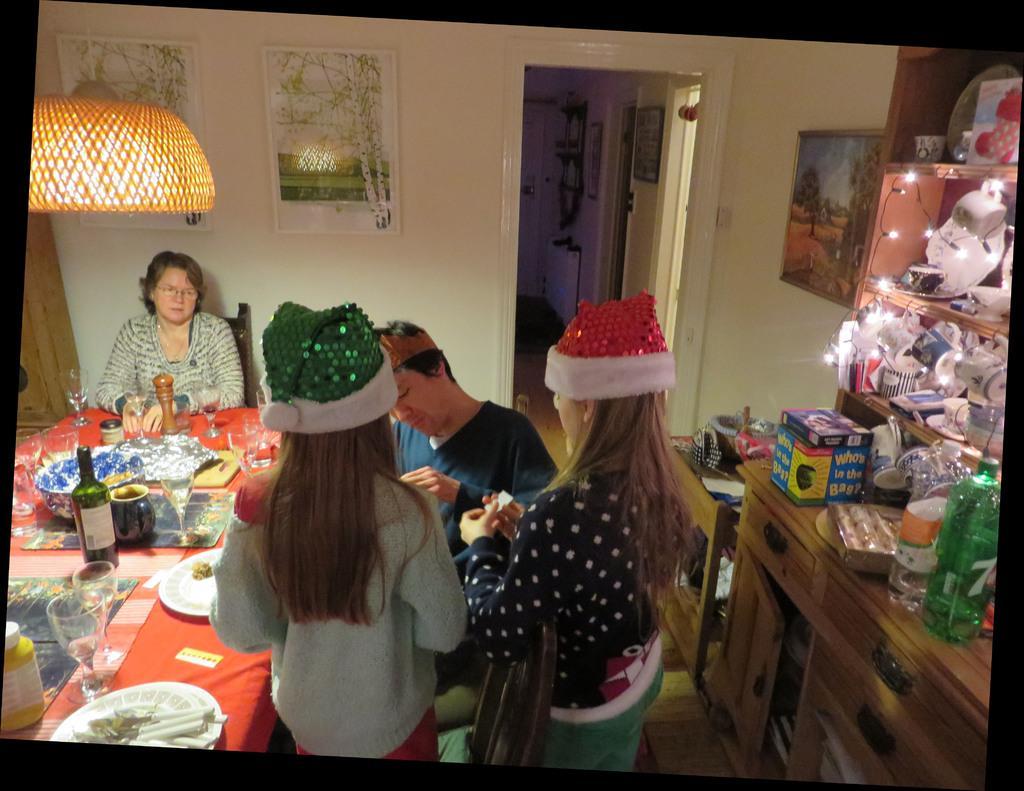Can you describe this image briefly? There are two girls standing and wearing caps. in front of them, there is a man sitting. Beside them, there are plates, glasses, and some other objects on the table which is covered with red color cloth. In the background, there is a woman sitting and watching them, a wall, posters on the wall, light. On the right hand side of the image, bottles and other materials on the table, some objects in the desks, lights, cups, and other items on the desk. 